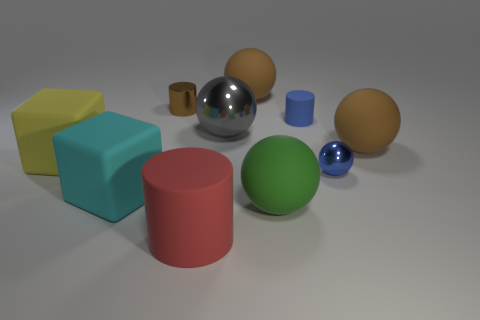Subtract 2 spheres. How many spheres are left? 3 Subtract all gray balls. How many balls are left? 4 Subtract all big green rubber balls. How many balls are left? 4 Subtract all purple spheres. Subtract all blue cylinders. How many spheres are left? 5 Subtract all cylinders. How many objects are left? 7 Subtract 0 yellow cylinders. How many objects are left? 10 Subtract all big red cylinders. Subtract all gray metal objects. How many objects are left? 8 Add 5 large green matte objects. How many large green matte objects are left? 6 Add 7 gray matte things. How many gray matte things exist? 7 